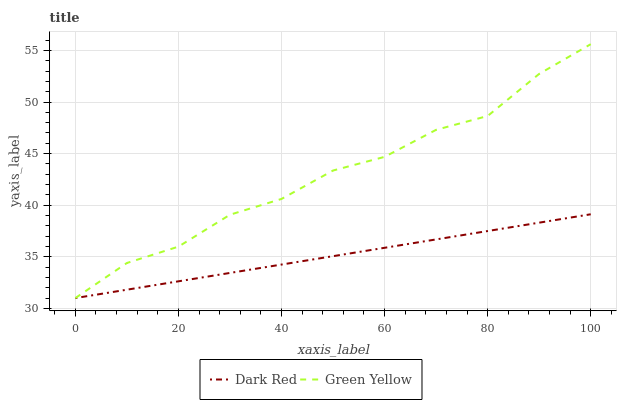Does Dark Red have the minimum area under the curve?
Answer yes or no. Yes. Does Green Yellow have the maximum area under the curve?
Answer yes or no. Yes. Does Green Yellow have the minimum area under the curve?
Answer yes or no. No. Is Dark Red the smoothest?
Answer yes or no. Yes. Is Green Yellow the roughest?
Answer yes or no. Yes. Is Green Yellow the smoothest?
Answer yes or no. No. Does Dark Red have the lowest value?
Answer yes or no. Yes. Does Green Yellow have the highest value?
Answer yes or no. Yes. Does Dark Red intersect Green Yellow?
Answer yes or no. Yes. Is Dark Red less than Green Yellow?
Answer yes or no. No. Is Dark Red greater than Green Yellow?
Answer yes or no. No. 